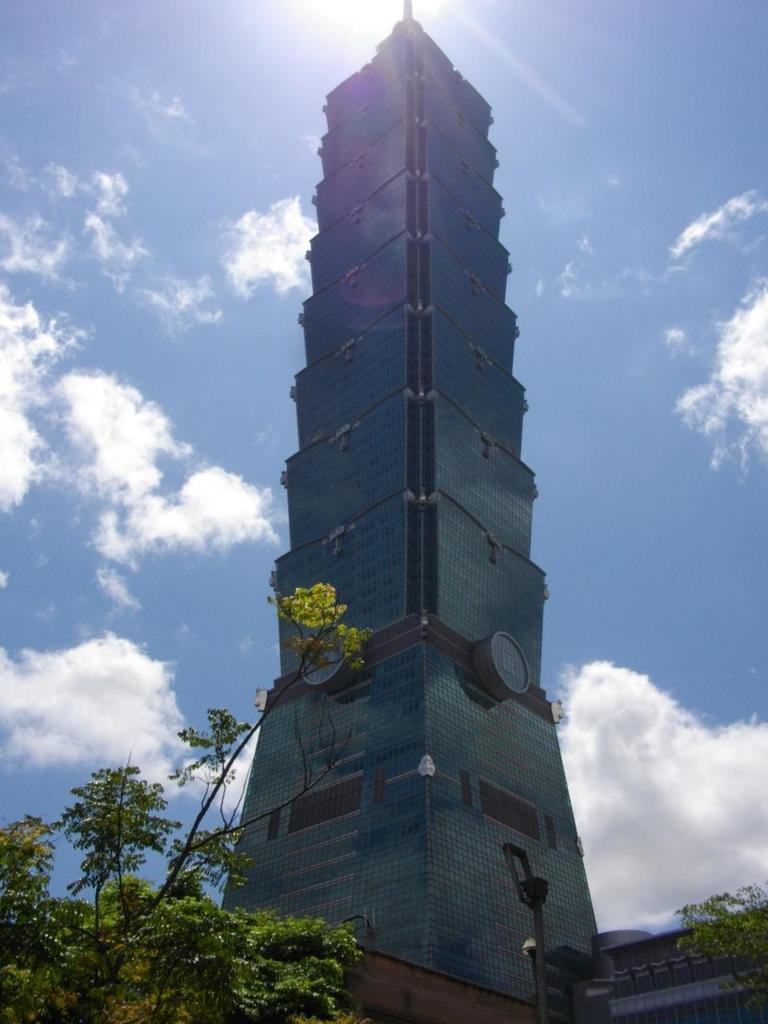Describe this image in one or two sentences. In this image, I can see a building. At the bottom of the image, there are trees and a pole. In the background, there is the sky. 